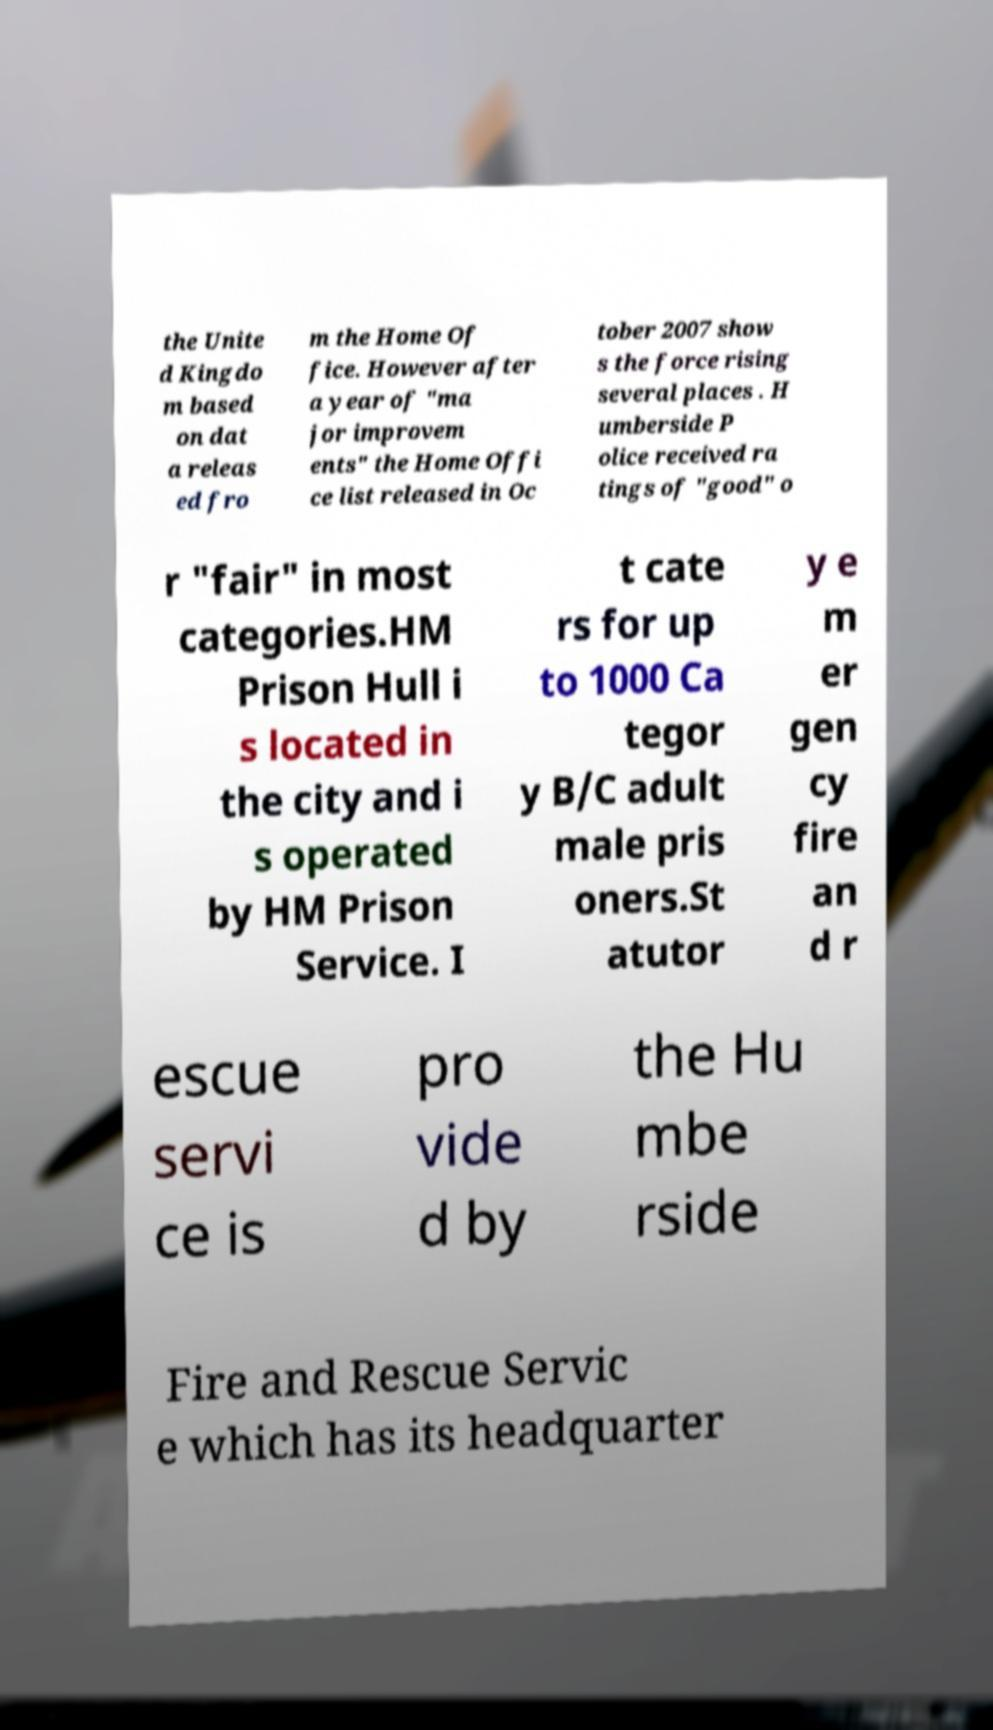Please identify and transcribe the text found in this image. the Unite d Kingdo m based on dat a releas ed fro m the Home Of fice. However after a year of "ma jor improvem ents" the Home Offi ce list released in Oc tober 2007 show s the force rising several places . H umberside P olice received ra tings of "good" o r "fair" in most categories.HM Prison Hull i s located in the city and i s operated by HM Prison Service. I t cate rs for up to 1000 Ca tegor y B/C adult male pris oners.St atutor y e m er gen cy fire an d r escue servi ce is pro vide d by the Hu mbe rside Fire and Rescue Servic e which has its headquarter 